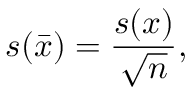<formula> <loc_0><loc_0><loc_500><loc_500>s ( \bar { x } ) = \frac { s ( x ) } { \sqrt { n } } ,</formula> 